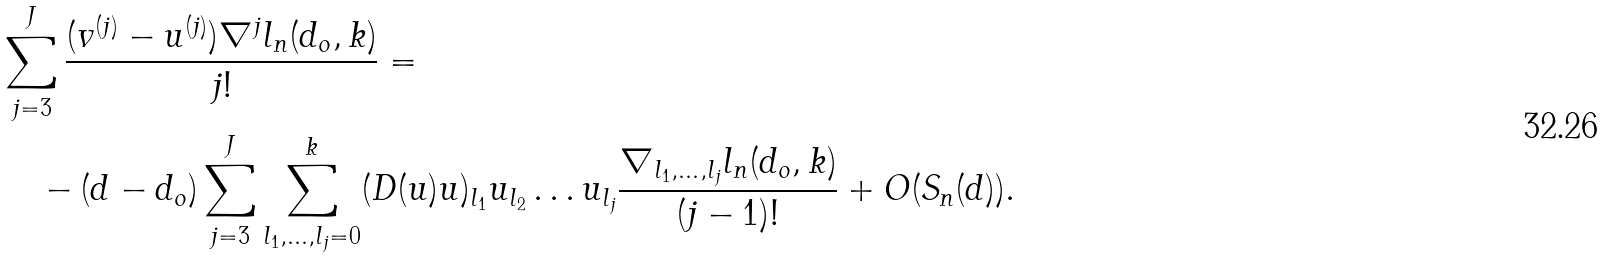Convert formula to latex. <formula><loc_0><loc_0><loc_500><loc_500>& \sum _ { j = 3 } ^ { J } \frac { ( v ^ { ( j ) } - u ^ { ( j ) } ) \nabla ^ { j } l _ { n } ( d _ { o } , k ) } { j ! } = \\ & \quad - ( d - d _ { o } ) \sum _ { j = 3 } ^ { J } \sum _ { l _ { 1 } , \dots , l _ { j } = 0 } ^ { k } ( D ( u ) u ) _ { l _ { 1 } } u _ { l _ { 2 } } \dots u _ { l _ { j } } \frac { \nabla _ { l _ { 1 } , \dots , l _ { j } } l _ { n } ( d _ { o } , k ) } { ( j - 1 ) ! } + O ( S _ { n } ( d ) ) .</formula> 